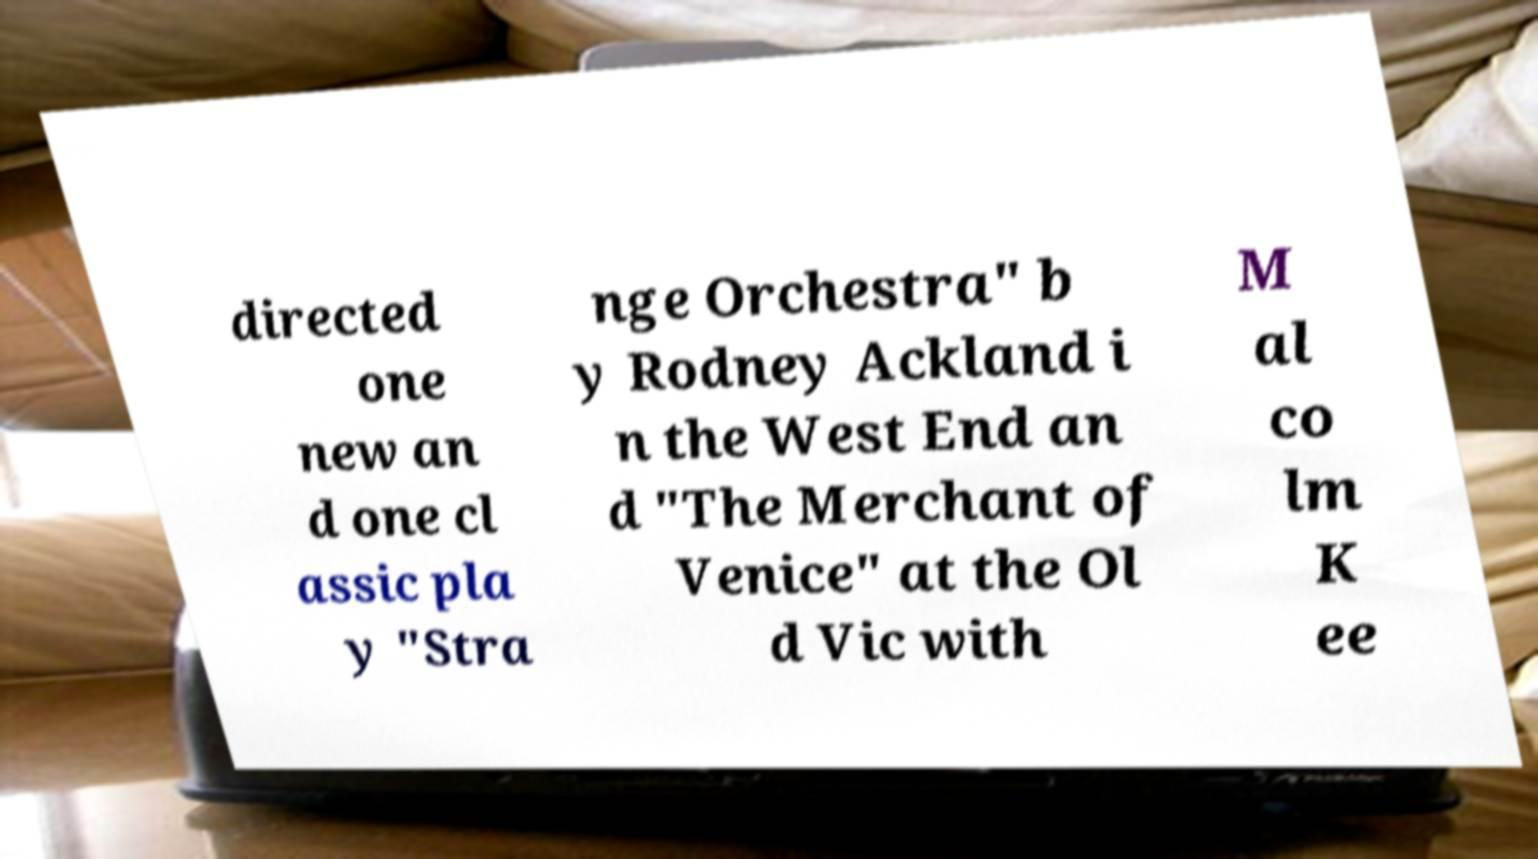Can you accurately transcribe the text from the provided image for me? directed one new an d one cl assic pla y "Stra nge Orchestra" b y Rodney Ackland i n the West End an d "The Merchant of Venice" at the Ol d Vic with M al co lm K ee 